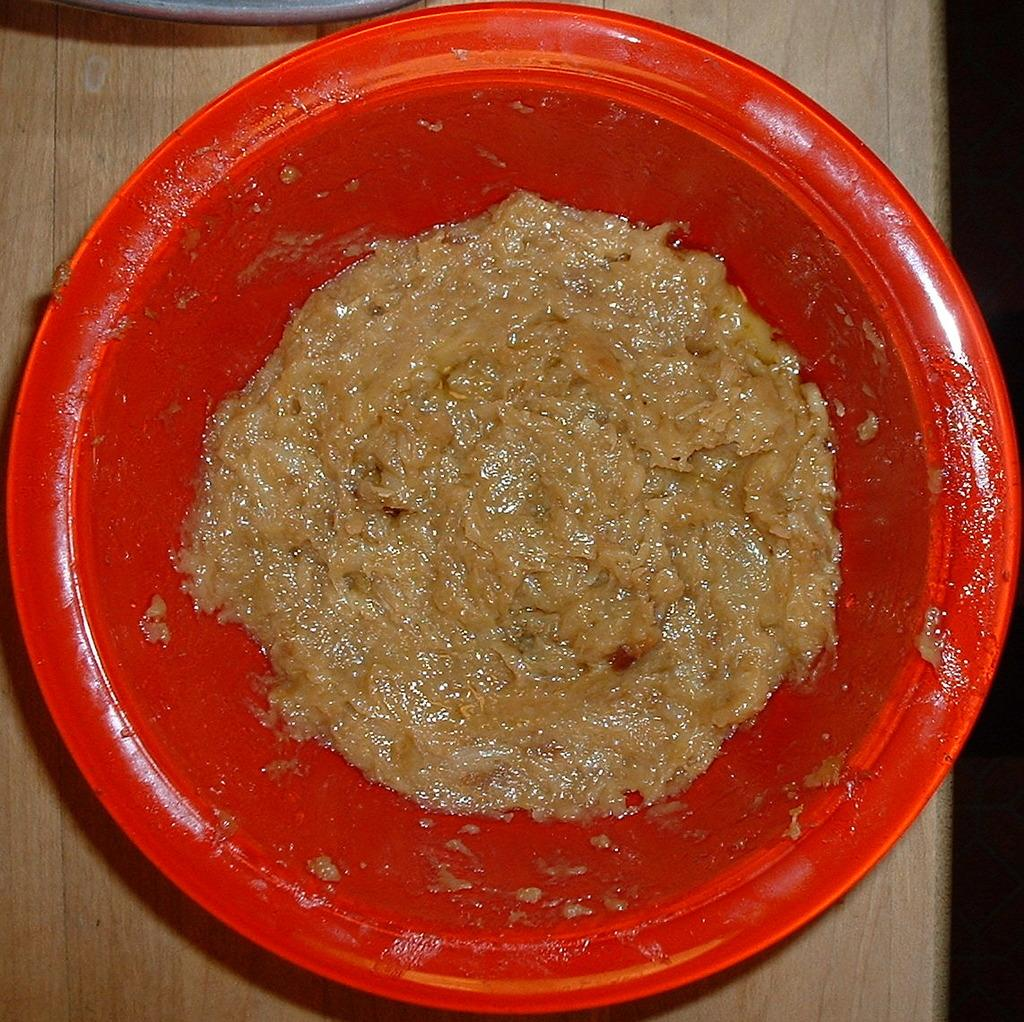What color is the bowl that is visible in the image? There is a red bowl in the image. What is inside the bowl in the image? There is food in the image. What type of surface is the red bowl placed on? The red bowl is on a wooden surface. How many houses are visible in the image? There are no houses visible in the image; it only features a red bowl with food on a wooden surface. 